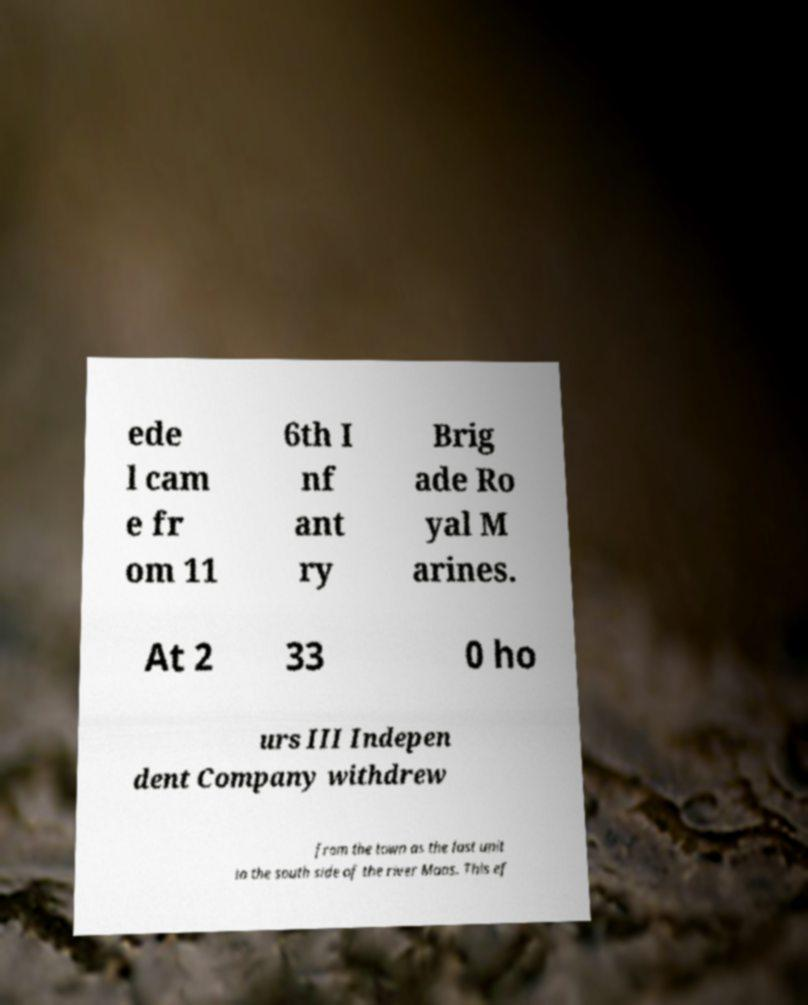I need the written content from this picture converted into text. Can you do that? ede l cam e fr om 11 6th I nf ant ry Brig ade Ro yal M arines. At 2 33 0 ho urs III Indepen dent Company withdrew from the town as the last unit to the south side of the river Maas. This ef 